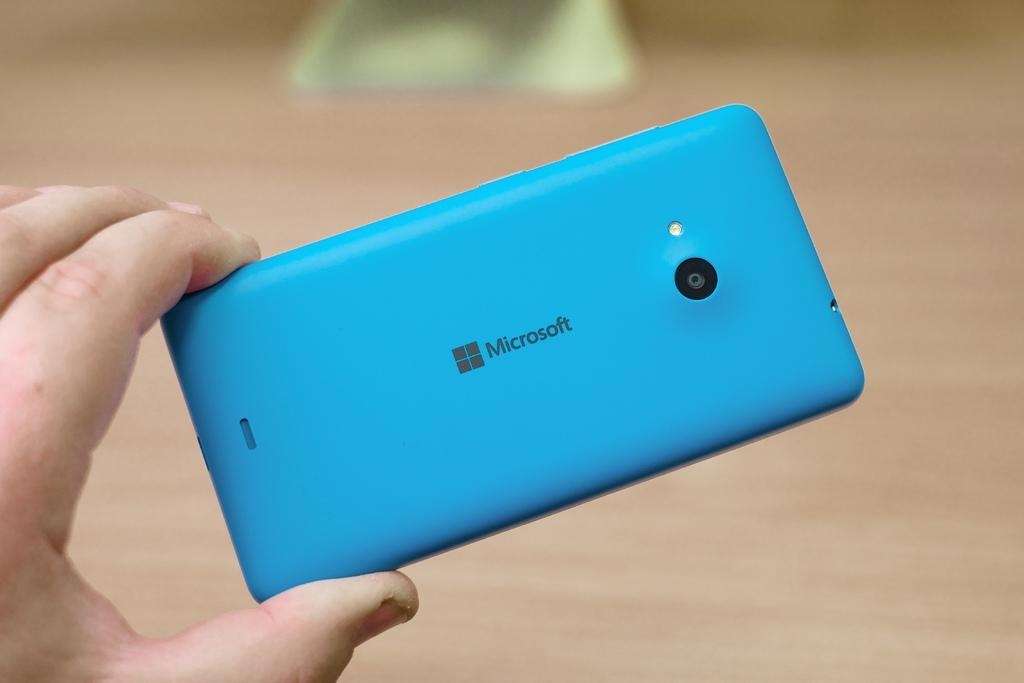What is the person holding in the image? The person is holding a mobile in the image. Can you describe the object on the floor in the image? Unfortunately, the facts provided do not give any details about the object on the floor. What type of fowl can be seen flying in the image? There is no fowl present in the image; it only shows a hand holding a mobile and an unspecified object on the floor. 